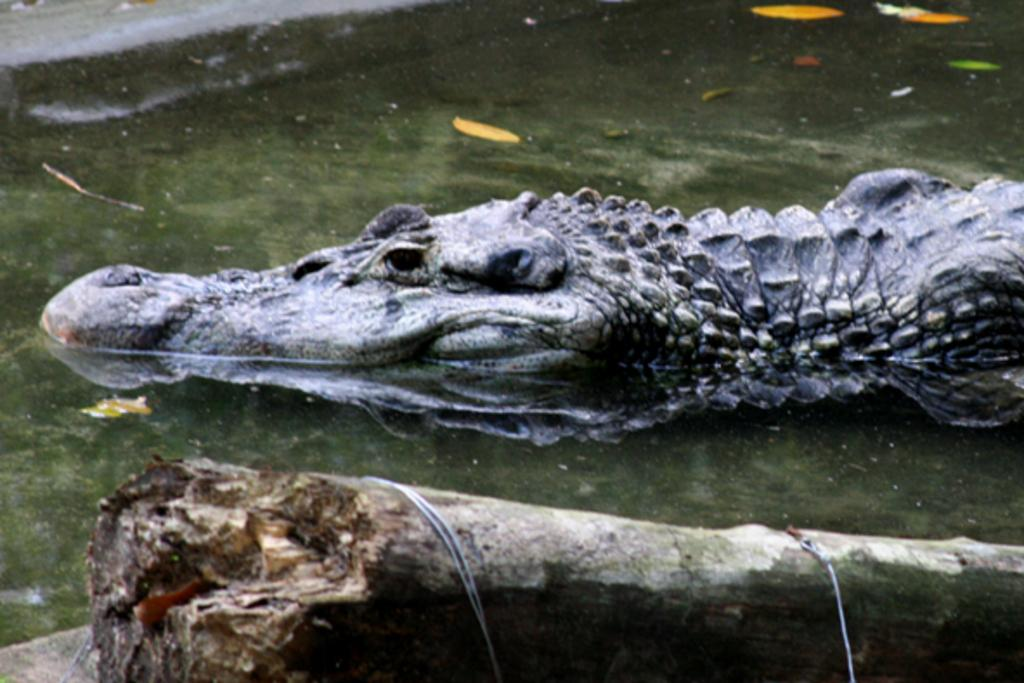What animal can be seen in the water in the image? There is a crocodile in the water in the image. What type of natural material is visible in the image? There is tree bark visible in the image. What type of rock can be seen in the image? There is no rock present in the image; it features a crocodile in the water and tree bark. Where is the nearest shop to the location of the image? The provided facts do not give any information about the location of the image, so it is impossible to determine the nearest shop. 